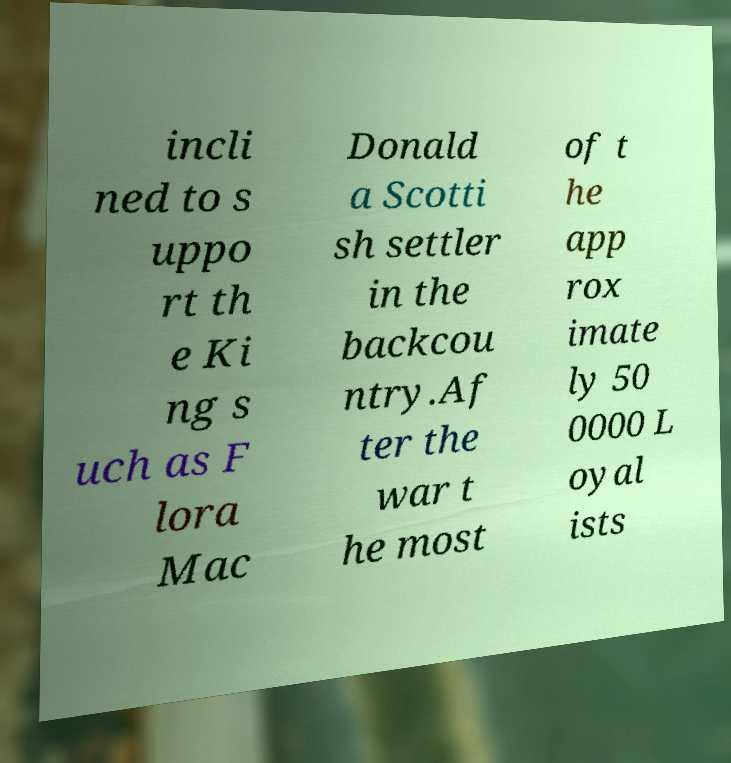Could you extract and type out the text from this image? incli ned to s uppo rt th e Ki ng s uch as F lora Mac Donald a Scotti sh settler in the backcou ntry.Af ter the war t he most of t he app rox imate ly 50 0000 L oyal ists 